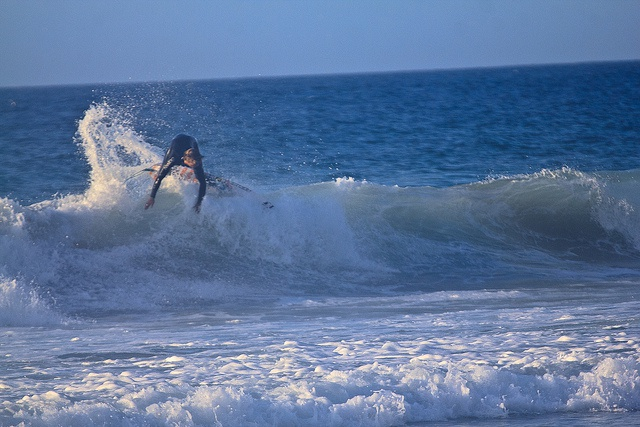Describe the objects in this image and their specific colors. I can see people in gray, navy, and darkblue tones and surfboard in gray, darkgray, and darkblue tones in this image. 